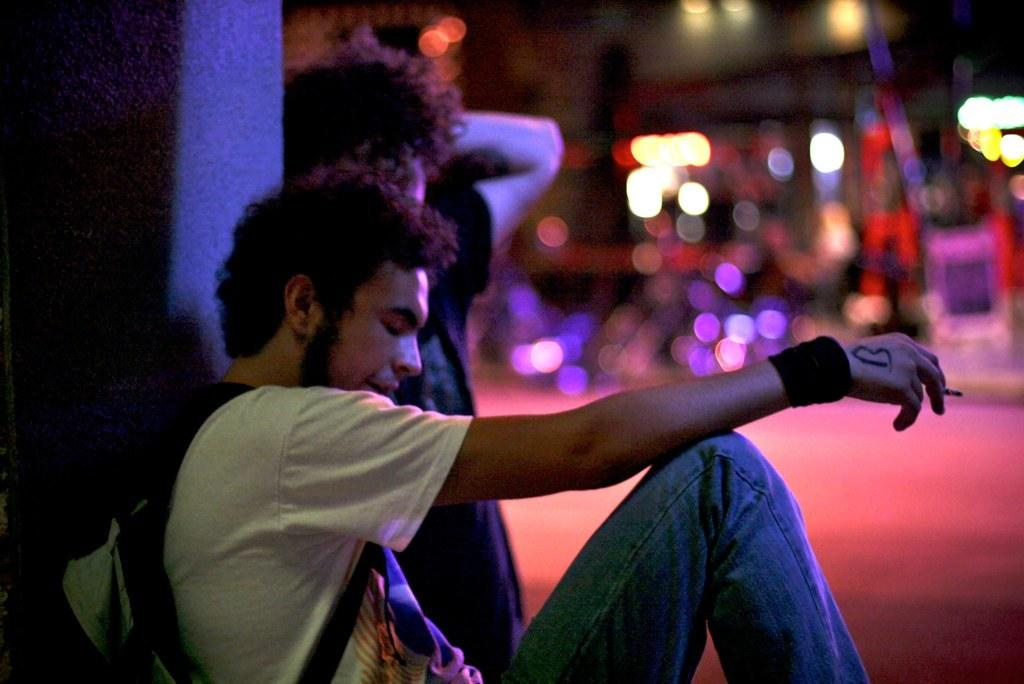What are the persons in the image doing? The persons in the image are sitting on the ground. Can you describe what one person is holding? One person is holding a cigarette. What is another person holding in the image? Another person is holding a bag. What type of yoke can be seen in the image? There is no yoke present in the image. How does the fear of the unknown affect the persons in the image? The image does not provide any information about the fear of the unknown or its effects on the persons in the image. 